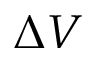<formula> <loc_0><loc_0><loc_500><loc_500>\Delta V</formula> 